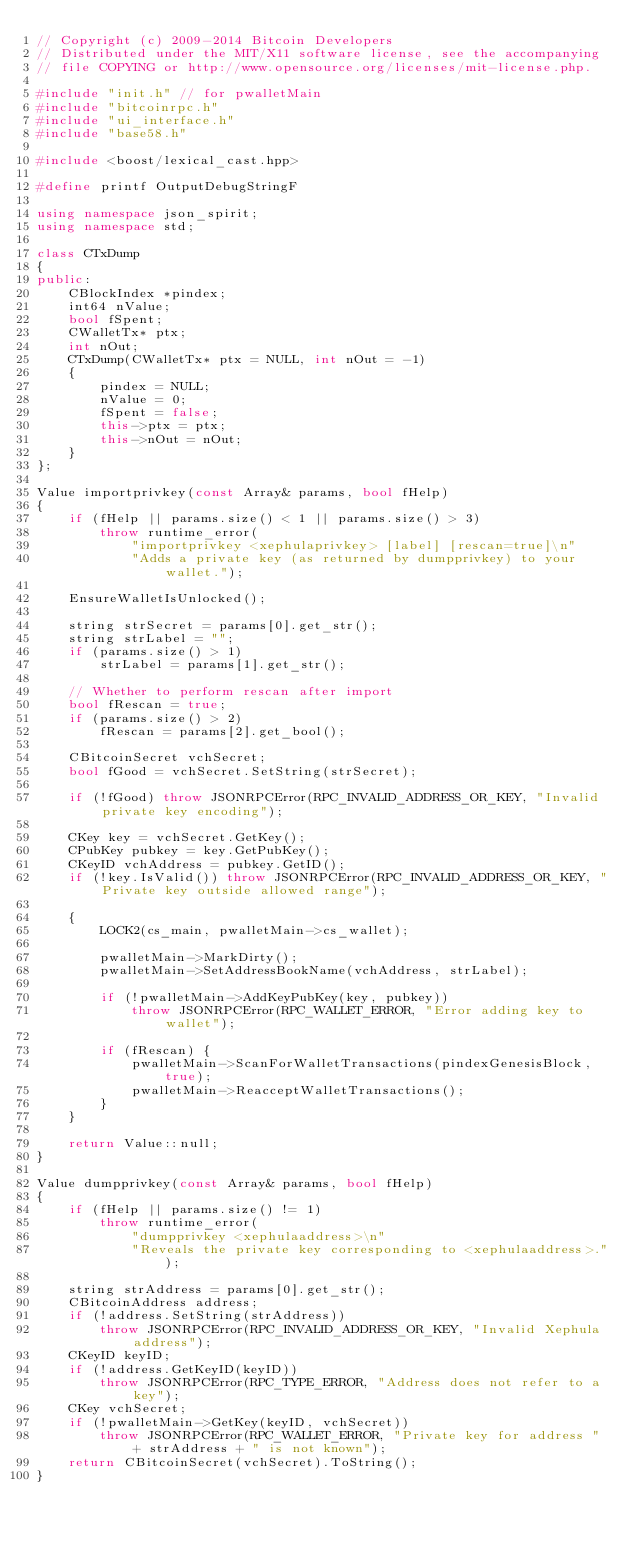Convert code to text. <code><loc_0><loc_0><loc_500><loc_500><_C++_>// Copyright (c) 2009-2014 Bitcoin Developers
// Distributed under the MIT/X11 software license, see the accompanying
// file COPYING or http://www.opensource.org/licenses/mit-license.php.

#include "init.h" // for pwalletMain
#include "bitcoinrpc.h"
#include "ui_interface.h"
#include "base58.h"

#include <boost/lexical_cast.hpp>

#define printf OutputDebugStringF

using namespace json_spirit;
using namespace std;

class CTxDump
{
public:
    CBlockIndex *pindex;
    int64 nValue;
    bool fSpent;
    CWalletTx* ptx;
    int nOut;
    CTxDump(CWalletTx* ptx = NULL, int nOut = -1)
    {
        pindex = NULL;
        nValue = 0;
        fSpent = false;
        this->ptx = ptx;
        this->nOut = nOut;
    }
};

Value importprivkey(const Array& params, bool fHelp)
{
    if (fHelp || params.size() < 1 || params.size() > 3)
        throw runtime_error(
            "importprivkey <xephulaprivkey> [label] [rescan=true]\n"
            "Adds a private key (as returned by dumpprivkey) to your wallet.");

    EnsureWalletIsUnlocked();

    string strSecret = params[0].get_str();
    string strLabel = "";
    if (params.size() > 1)
        strLabel = params[1].get_str();

    // Whether to perform rescan after import
    bool fRescan = true;
    if (params.size() > 2)
        fRescan = params[2].get_bool();

    CBitcoinSecret vchSecret;
    bool fGood = vchSecret.SetString(strSecret);

    if (!fGood) throw JSONRPCError(RPC_INVALID_ADDRESS_OR_KEY, "Invalid private key encoding");

    CKey key = vchSecret.GetKey();
    CPubKey pubkey = key.GetPubKey();
    CKeyID vchAddress = pubkey.GetID();
    if (!key.IsValid()) throw JSONRPCError(RPC_INVALID_ADDRESS_OR_KEY, "Private key outside allowed range");

    {
        LOCK2(cs_main, pwalletMain->cs_wallet);

        pwalletMain->MarkDirty();
        pwalletMain->SetAddressBookName(vchAddress, strLabel);

        if (!pwalletMain->AddKeyPubKey(key, pubkey))
            throw JSONRPCError(RPC_WALLET_ERROR, "Error adding key to wallet");

        if (fRescan) {
            pwalletMain->ScanForWalletTransactions(pindexGenesisBlock, true);
            pwalletMain->ReacceptWalletTransactions();
        }
    }

    return Value::null;
}

Value dumpprivkey(const Array& params, bool fHelp)
{
    if (fHelp || params.size() != 1)
        throw runtime_error(
            "dumpprivkey <xephulaaddress>\n"
            "Reveals the private key corresponding to <xephulaaddress>.");

    string strAddress = params[0].get_str();
    CBitcoinAddress address;
    if (!address.SetString(strAddress))
        throw JSONRPCError(RPC_INVALID_ADDRESS_OR_KEY, "Invalid Xephula address");
    CKeyID keyID;
    if (!address.GetKeyID(keyID))
        throw JSONRPCError(RPC_TYPE_ERROR, "Address does not refer to a key");
    CKey vchSecret;
    if (!pwalletMain->GetKey(keyID, vchSecret))
        throw JSONRPCError(RPC_WALLET_ERROR, "Private key for address " + strAddress + " is not known");
    return CBitcoinSecret(vchSecret).ToString();
}
</code> 